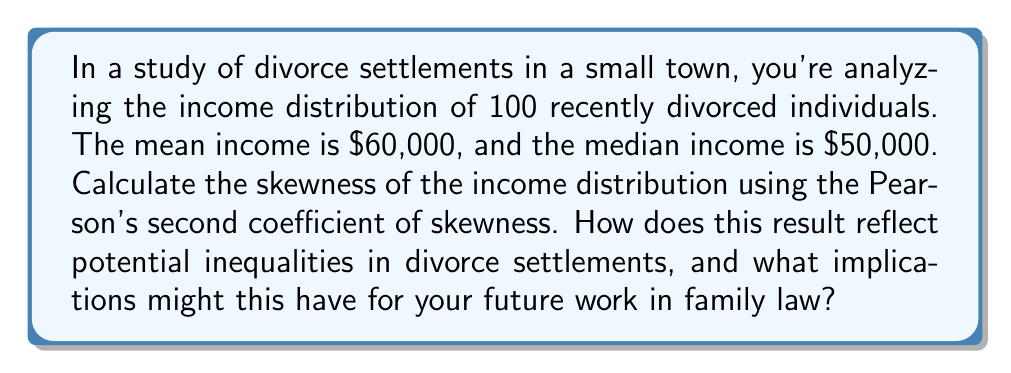Help me with this question. To solve this problem and understand its implications for family law, let's follow these steps:

1) The Pearson's second coefficient of skewness is given by the formula:

   $$ \text{Skewness} = \frac{3(\text{Mean} - \text{Median})}{\text{Standard Deviation}} $$

2) We're given the Mean ($60,000) and Median ($50,000), but we need to estimate the Standard Deviation.

3) Without more data, we can't calculate the exact Standard Deviation. However, for many real-world income distributions, the Standard Deviation is often close to the Mean. Let's use this as an approximation:

   $$ \text{Standard Deviation} \approx 60,000 $$

4) Now we can calculate the skewness:

   $$ \text{Skewness} = \frac{3(60,000 - 50,000)}{60,000} = \frac{3(10,000)}{60,000} = 0.5 $$

5) A positive skewness indicates that the distribution has a long tail on the right side. In the context of income distribution, this means there are a few high-income outliers pulling the mean above the median.

6) For family law practice, this suggests:
   - The majority of divorced individuals have incomes below the mean.
   - A small number of high-income individuals are significantly affecting the average.
   - There may be substantial income inequality among divorced individuals.
   - This could point to potential issues in how assets and support are determined in divorce settlements, possibly favoring higher-income individuals.

This analysis provides a contrasting viewpoint to corporate practices by highlighting potential economic disparities in divorce outcomes, which could inform more equitable approaches to family law.
Answer: The skewness of the income distribution is approximately 0.5, indicating a moderate positive skew. 